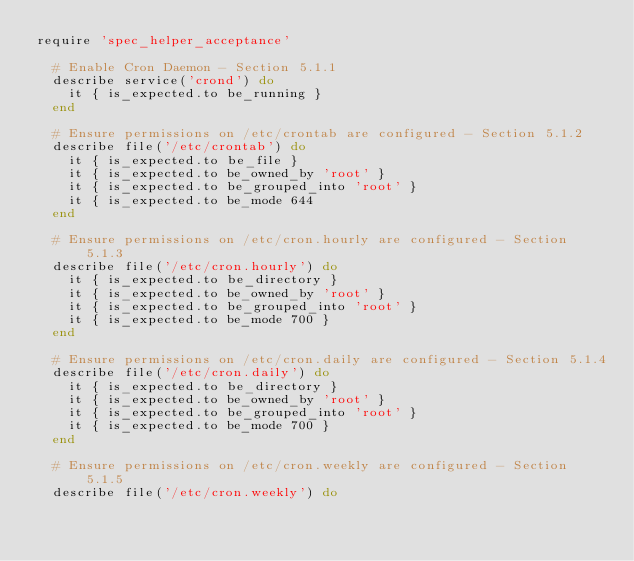Convert code to text. <code><loc_0><loc_0><loc_500><loc_500><_Ruby_>require 'spec_helper_acceptance'

  # Enable Cron Daemon - Section 5.1.1
  describe service('crond') do
    it { is_expected.to be_running }
  end

  # Ensure permissions on /etc/crontab are configured - Section 5.1.2
  describe file('/etc/crontab') do
    it { is_expected.to be_file }
    it { is_expected.to be_owned_by 'root' }
    it { is_expected.to be_grouped_into 'root' }
    it { is_expected.to be_mode 644
  end

  # Ensure permissions on /etc/cron.hourly are configured - Section 5.1.3
  describe file('/etc/cron.hourly') do
    it { is_expected.to be_directory }
    it { is_expected.to be_owned_by 'root' }
    it { is_expected.to be_grouped_into 'root' }
    it { is_expected.to be_mode 700 }
  end

  # Ensure permissions on /etc/cron.daily are configured - Section 5.1.4
  describe file('/etc/cron.daily') do
    it { is_expected.to be_directory }
    it { is_expected.to be_owned_by 'root' }
    it { is_expected.to be_grouped_into 'root' }
    it { is_expected.to be_mode 700 }
  end

  # Ensure permissions on /etc/cron.weekly are configured - Section 5.1.5
  describe file('/etc/cron.weekly') do</code> 